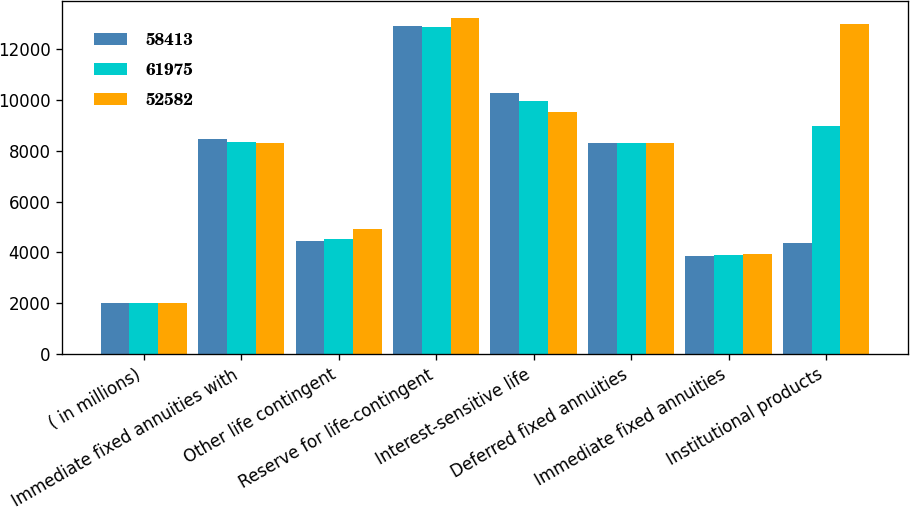<chart> <loc_0><loc_0><loc_500><loc_500><stacked_bar_chart><ecel><fcel>( in millions)<fcel>Immediate fixed annuities with<fcel>Other life contingent<fcel>Reserve for life-contingent<fcel>Interest-sensitive life<fcel>Deferred fixed annuities<fcel>Immediate fixed annuities<fcel>Institutional products<nl><fcel>58413<fcel>2009<fcel>8454<fcel>4456<fcel>12910<fcel>10276<fcel>8294<fcel>3869<fcel>4370<nl><fcel>61975<fcel>2008<fcel>8355<fcel>4526<fcel>12881<fcel>9957<fcel>8294<fcel>3894<fcel>8974<nl><fcel>52582<fcel>2007<fcel>8294<fcel>4918<fcel>13212<fcel>9539<fcel>8294<fcel>3921<fcel>12983<nl></chart> 